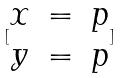Convert formula to latex. <formula><loc_0><loc_0><loc_500><loc_500>[ \begin{matrix} x & = & p \\ y & = & p \end{matrix} ]</formula> 